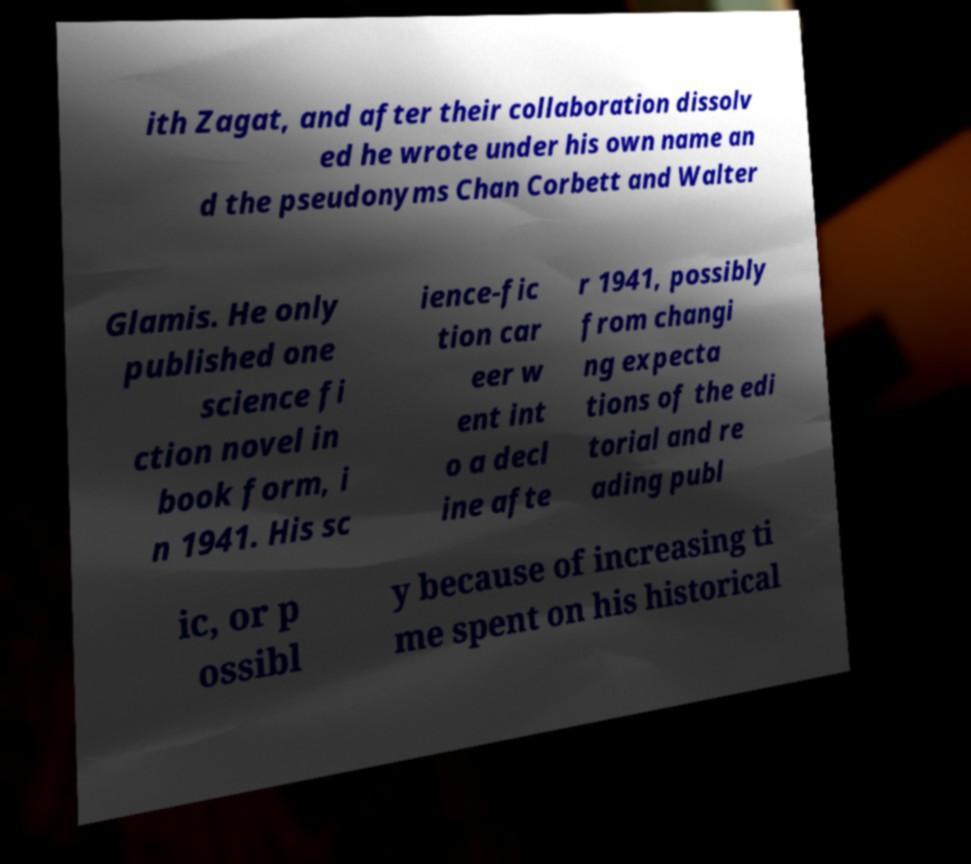For documentation purposes, I need the text within this image transcribed. Could you provide that? ith Zagat, and after their collaboration dissolv ed he wrote under his own name an d the pseudonyms Chan Corbett and Walter Glamis. He only published one science fi ction novel in book form, i n 1941. His sc ience-fic tion car eer w ent int o a decl ine afte r 1941, possibly from changi ng expecta tions of the edi torial and re ading publ ic, or p ossibl y because of increasing ti me spent on his historical 